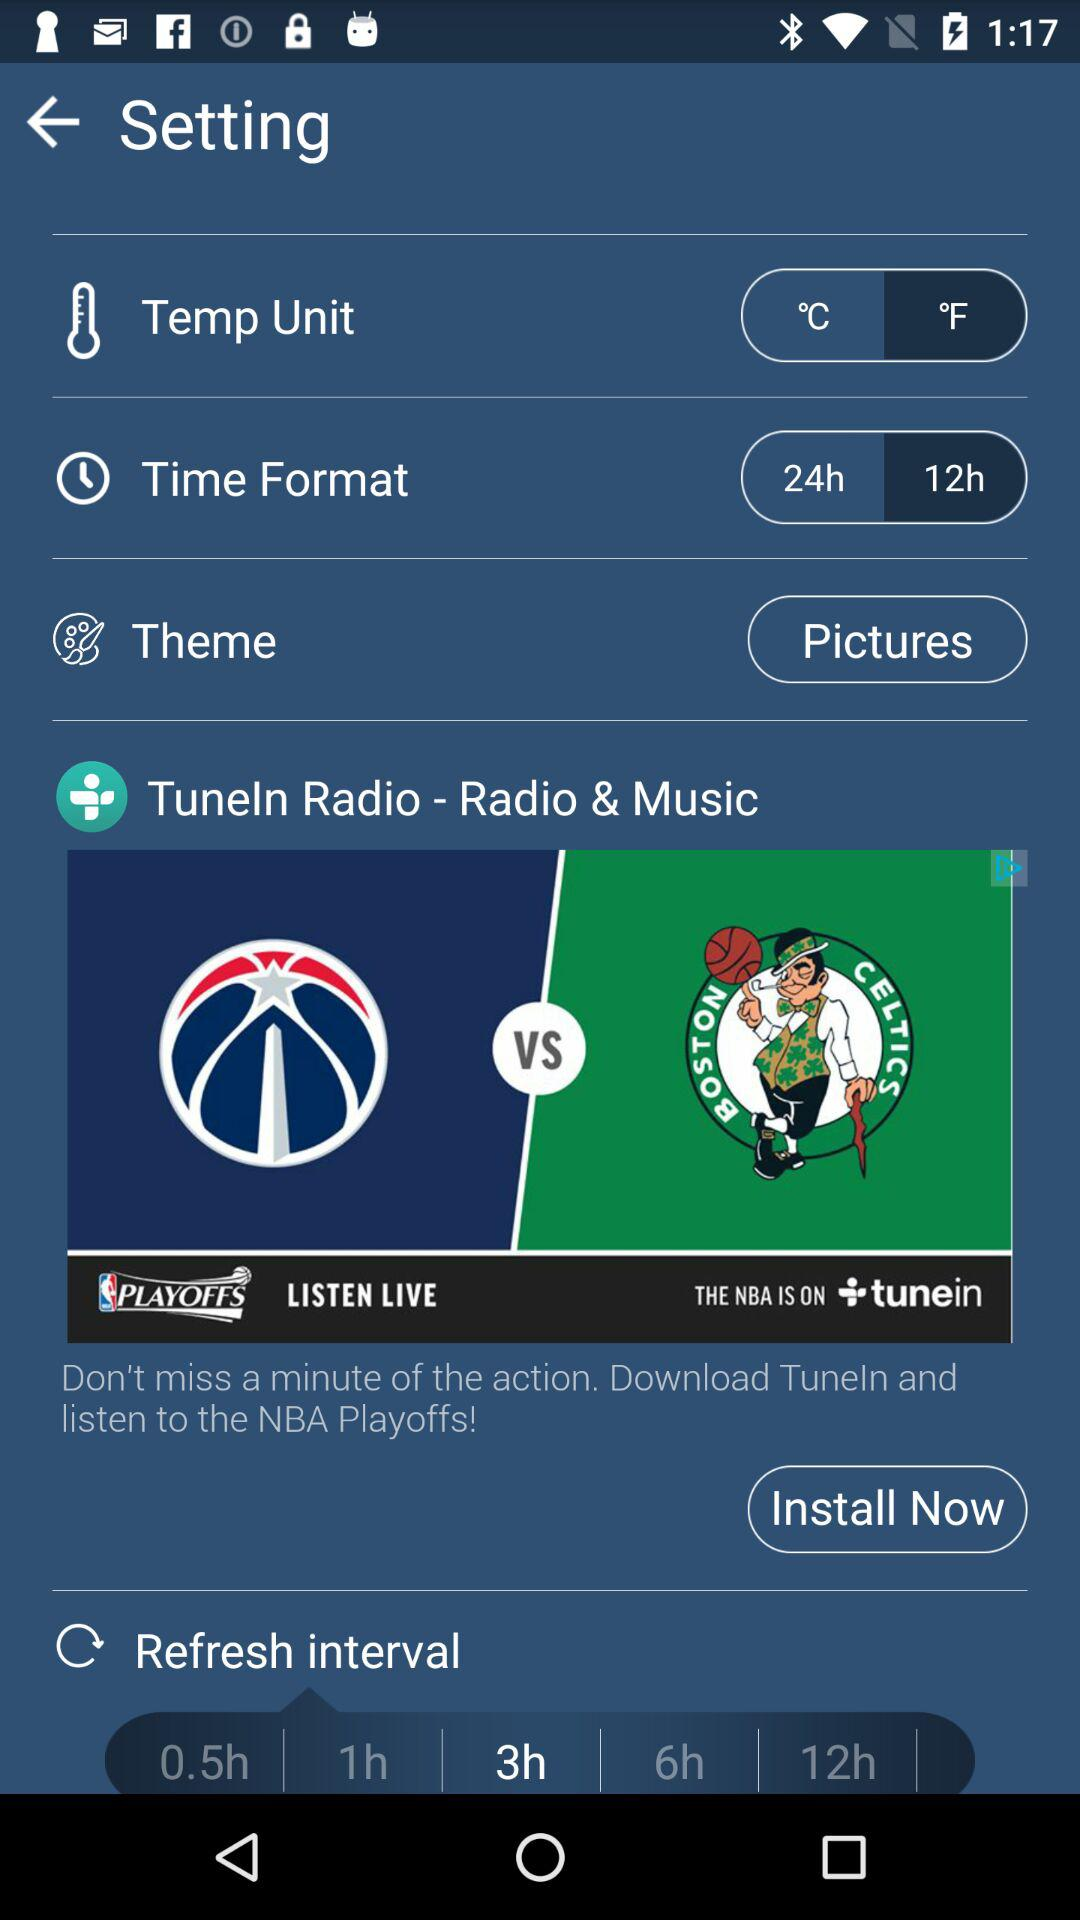Which option in the temperature unit is selected? The selected option is "°F". 